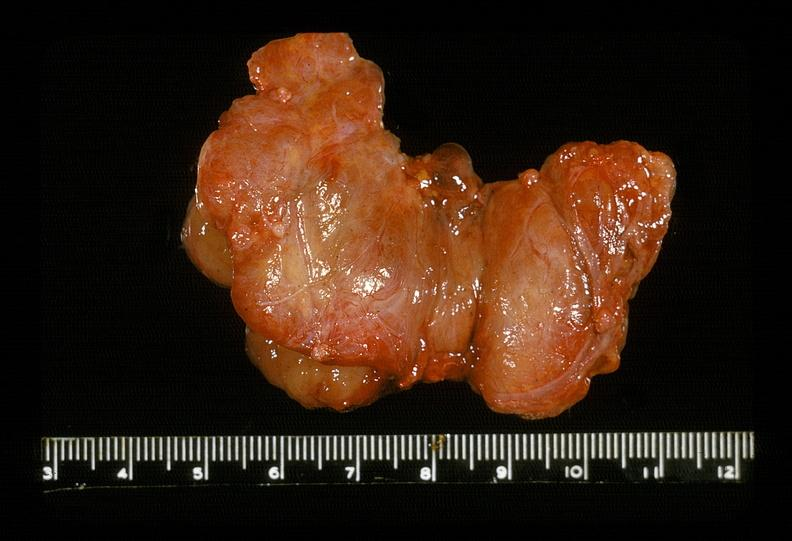what is present?
Answer the question using a single word or phrase. Endocrine 